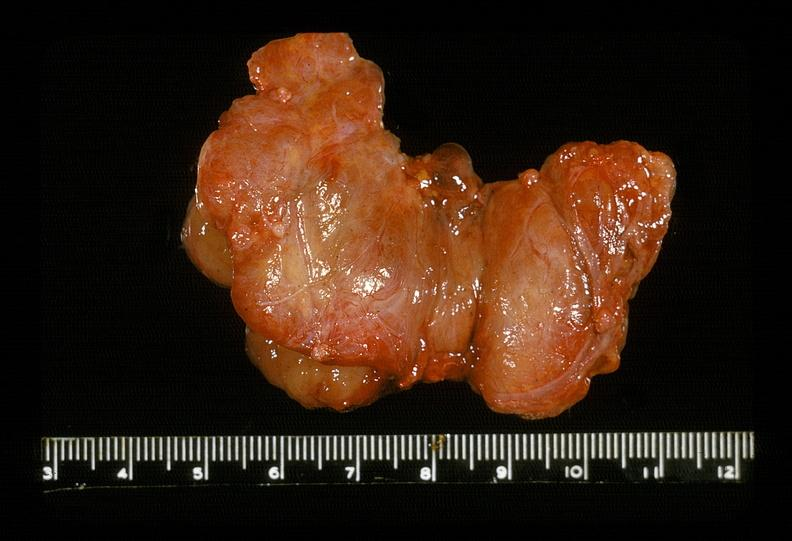what is present?
Answer the question using a single word or phrase. Endocrine 